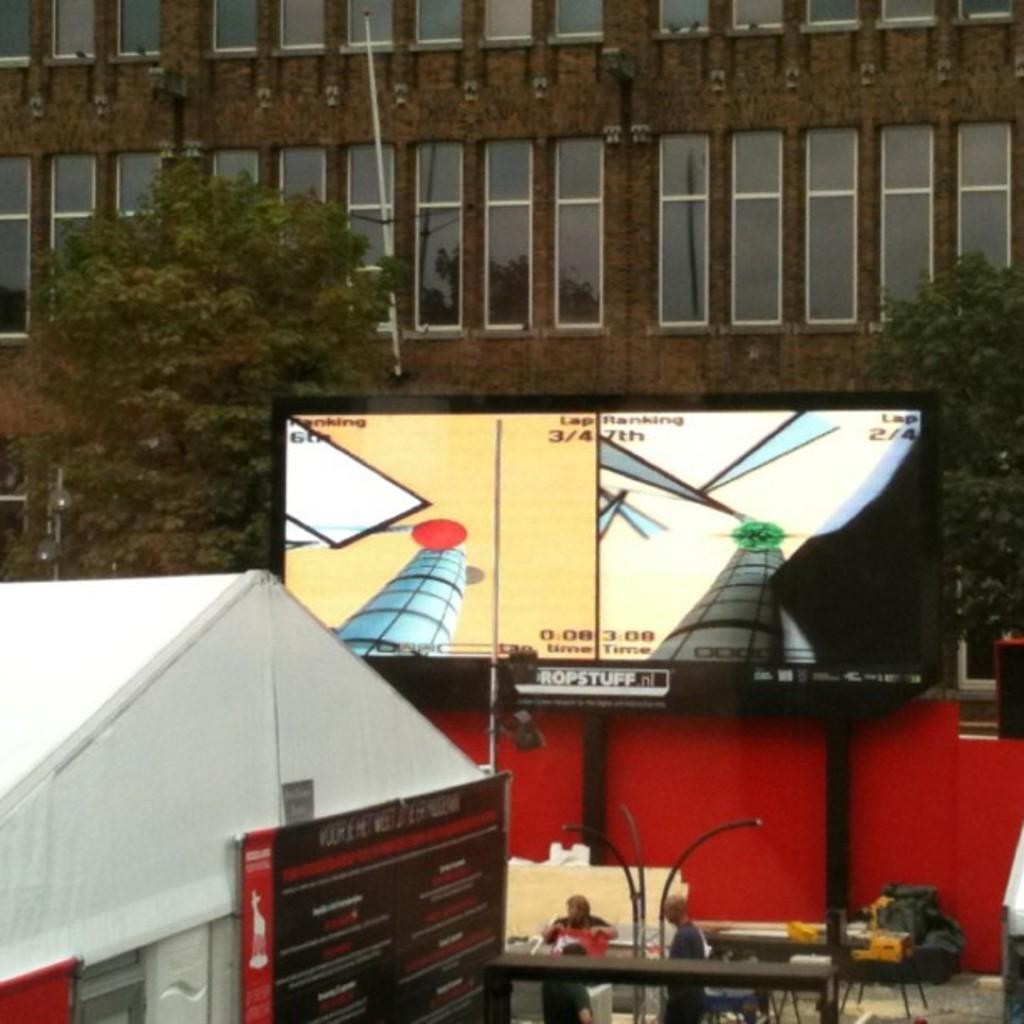How would you summarize this image in a sentence or two? In the image I can see few buildings, windows, trees, board, screen, light-poles, few people and few objects on the floor. 